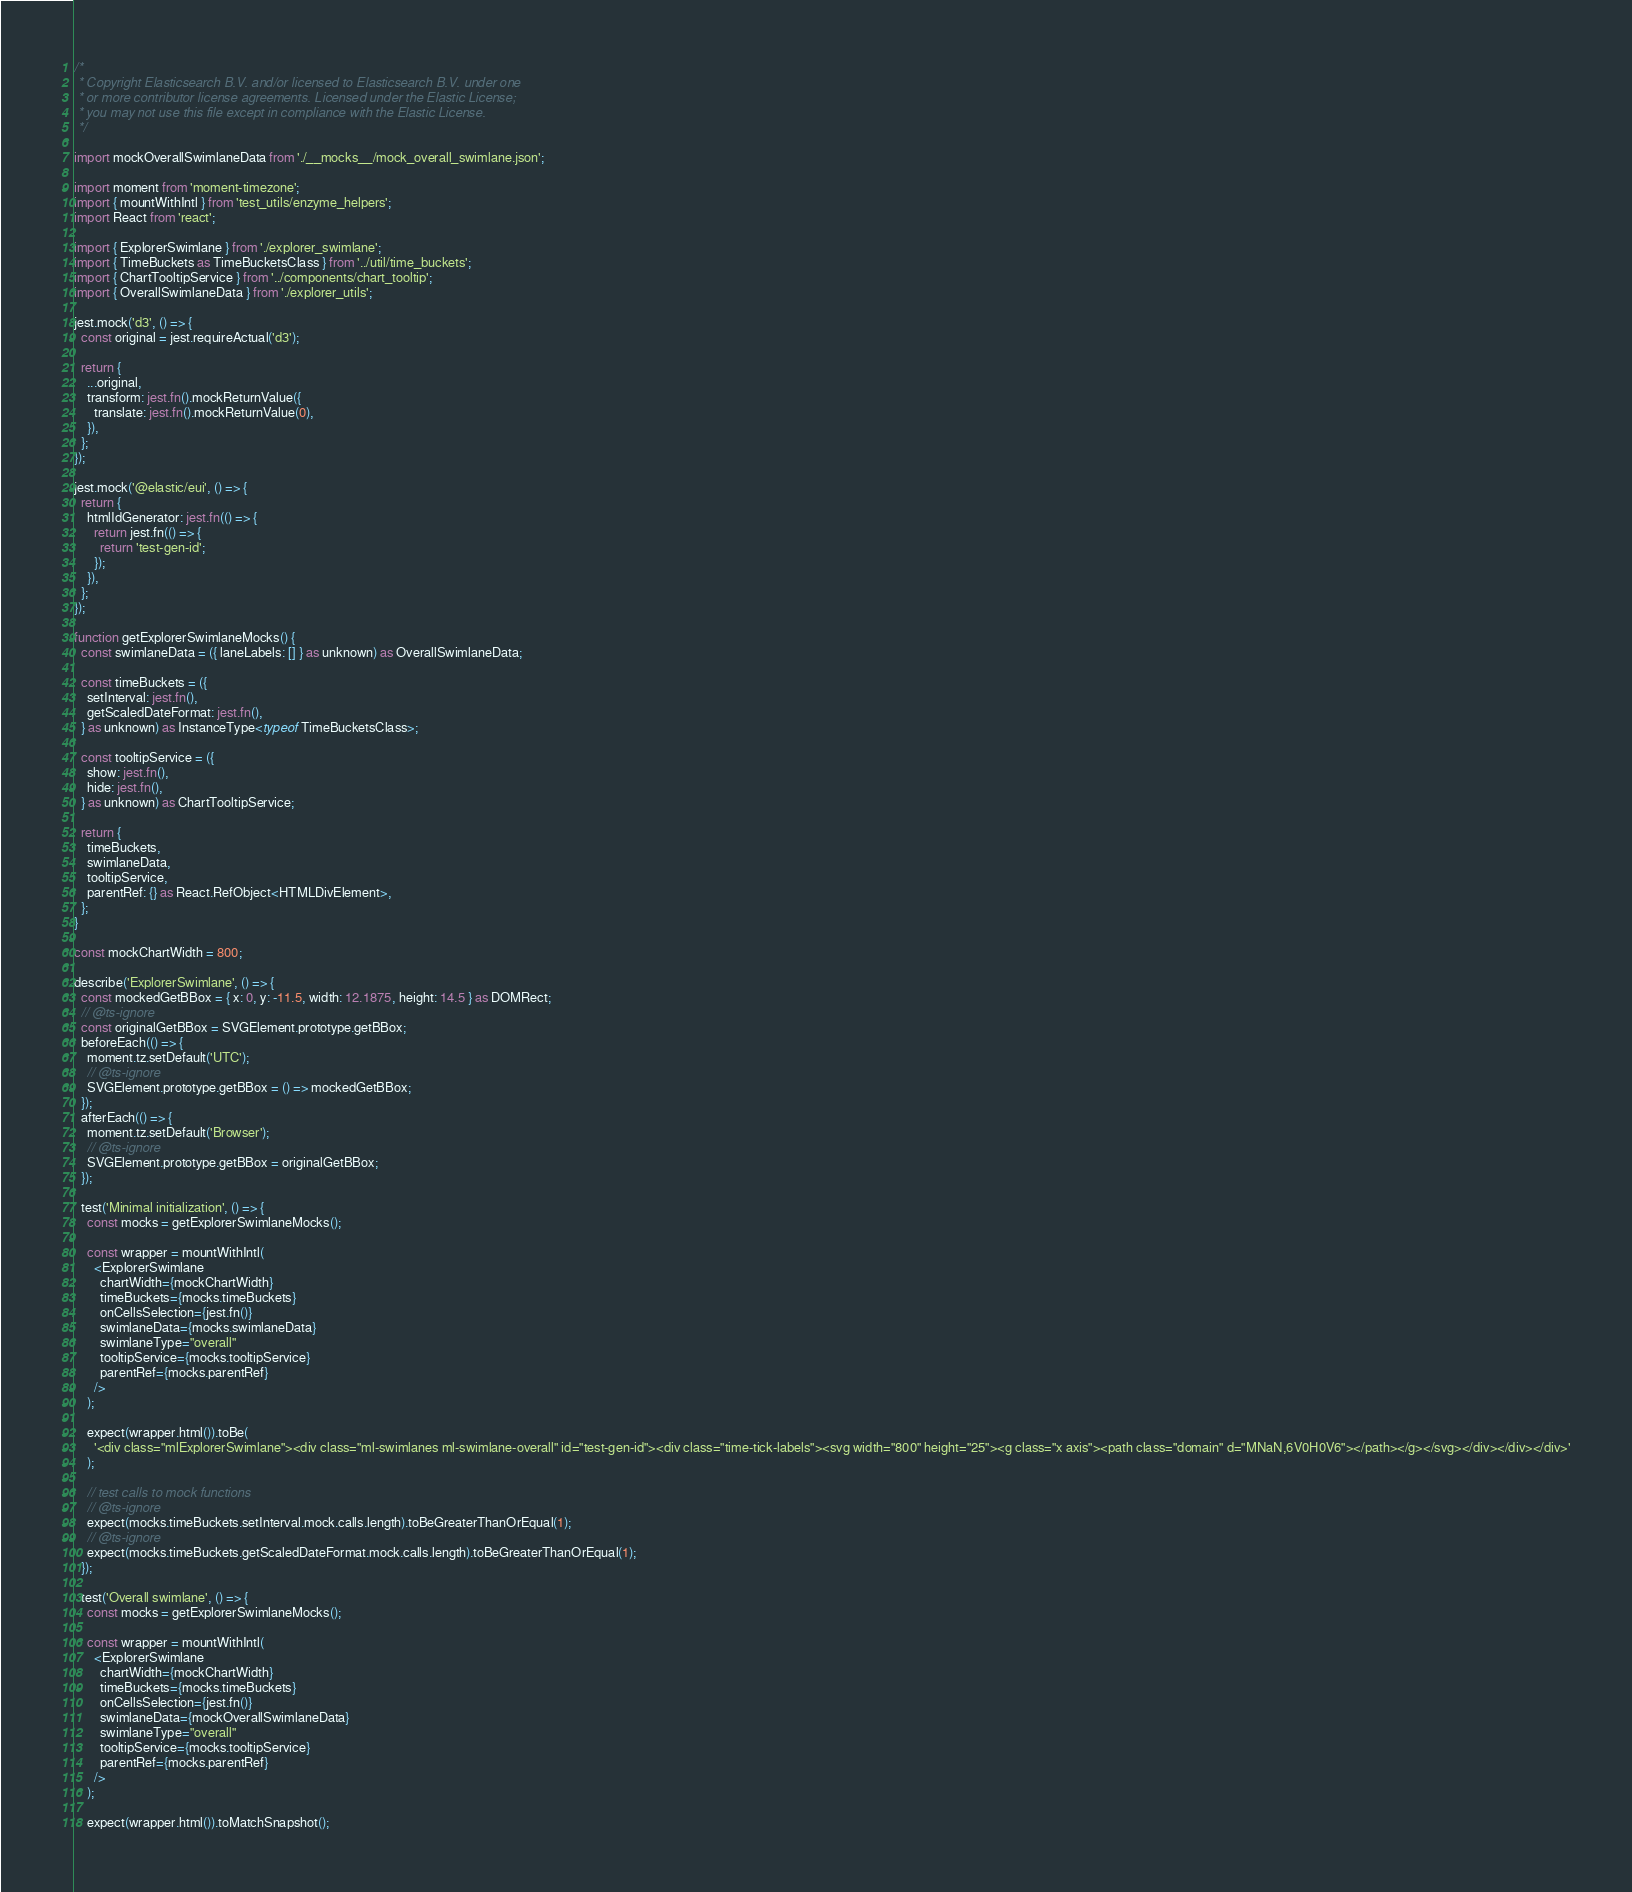Convert code to text. <code><loc_0><loc_0><loc_500><loc_500><_TypeScript_>/*
 * Copyright Elasticsearch B.V. and/or licensed to Elasticsearch B.V. under one
 * or more contributor license agreements. Licensed under the Elastic License;
 * you may not use this file except in compliance with the Elastic License.
 */

import mockOverallSwimlaneData from './__mocks__/mock_overall_swimlane.json';

import moment from 'moment-timezone';
import { mountWithIntl } from 'test_utils/enzyme_helpers';
import React from 'react';

import { ExplorerSwimlane } from './explorer_swimlane';
import { TimeBuckets as TimeBucketsClass } from '../util/time_buckets';
import { ChartTooltipService } from '../components/chart_tooltip';
import { OverallSwimlaneData } from './explorer_utils';

jest.mock('d3', () => {
  const original = jest.requireActual('d3');

  return {
    ...original,
    transform: jest.fn().mockReturnValue({
      translate: jest.fn().mockReturnValue(0),
    }),
  };
});

jest.mock('@elastic/eui', () => {
  return {
    htmlIdGenerator: jest.fn(() => {
      return jest.fn(() => {
        return 'test-gen-id';
      });
    }),
  };
});

function getExplorerSwimlaneMocks() {
  const swimlaneData = ({ laneLabels: [] } as unknown) as OverallSwimlaneData;

  const timeBuckets = ({
    setInterval: jest.fn(),
    getScaledDateFormat: jest.fn(),
  } as unknown) as InstanceType<typeof TimeBucketsClass>;

  const tooltipService = ({
    show: jest.fn(),
    hide: jest.fn(),
  } as unknown) as ChartTooltipService;

  return {
    timeBuckets,
    swimlaneData,
    tooltipService,
    parentRef: {} as React.RefObject<HTMLDivElement>,
  };
}

const mockChartWidth = 800;

describe('ExplorerSwimlane', () => {
  const mockedGetBBox = { x: 0, y: -11.5, width: 12.1875, height: 14.5 } as DOMRect;
  // @ts-ignore
  const originalGetBBox = SVGElement.prototype.getBBox;
  beforeEach(() => {
    moment.tz.setDefault('UTC');
    // @ts-ignore
    SVGElement.prototype.getBBox = () => mockedGetBBox;
  });
  afterEach(() => {
    moment.tz.setDefault('Browser');
    // @ts-ignore
    SVGElement.prototype.getBBox = originalGetBBox;
  });

  test('Minimal initialization', () => {
    const mocks = getExplorerSwimlaneMocks();

    const wrapper = mountWithIntl(
      <ExplorerSwimlane
        chartWidth={mockChartWidth}
        timeBuckets={mocks.timeBuckets}
        onCellsSelection={jest.fn()}
        swimlaneData={mocks.swimlaneData}
        swimlaneType="overall"
        tooltipService={mocks.tooltipService}
        parentRef={mocks.parentRef}
      />
    );

    expect(wrapper.html()).toBe(
      '<div class="mlExplorerSwimlane"><div class="ml-swimlanes ml-swimlane-overall" id="test-gen-id"><div class="time-tick-labels"><svg width="800" height="25"><g class="x axis"><path class="domain" d="MNaN,6V0H0V6"></path></g></svg></div></div></div>'
    );

    // test calls to mock functions
    // @ts-ignore
    expect(mocks.timeBuckets.setInterval.mock.calls.length).toBeGreaterThanOrEqual(1);
    // @ts-ignore
    expect(mocks.timeBuckets.getScaledDateFormat.mock.calls.length).toBeGreaterThanOrEqual(1);
  });

  test('Overall swimlane', () => {
    const mocks = getExplorerSwimlaneMocks();

    const wrapper = mountWithIntl(
      <ExplorerSwimlane
        chartWidth={mockChartWidth}
        timeBuckets={mocks.timeBuckets}
        onCellsSelection={jest.fn()}
        swimlaneData={mockOverallSwimlaneData}
        swimlaneType="overall"
        tooltipService={mocks.tooltipService}
        parentRef={mocks.parentRef}
      />
    );

    expect(wrapper.html()).toMatchSnapshot();
</code> 